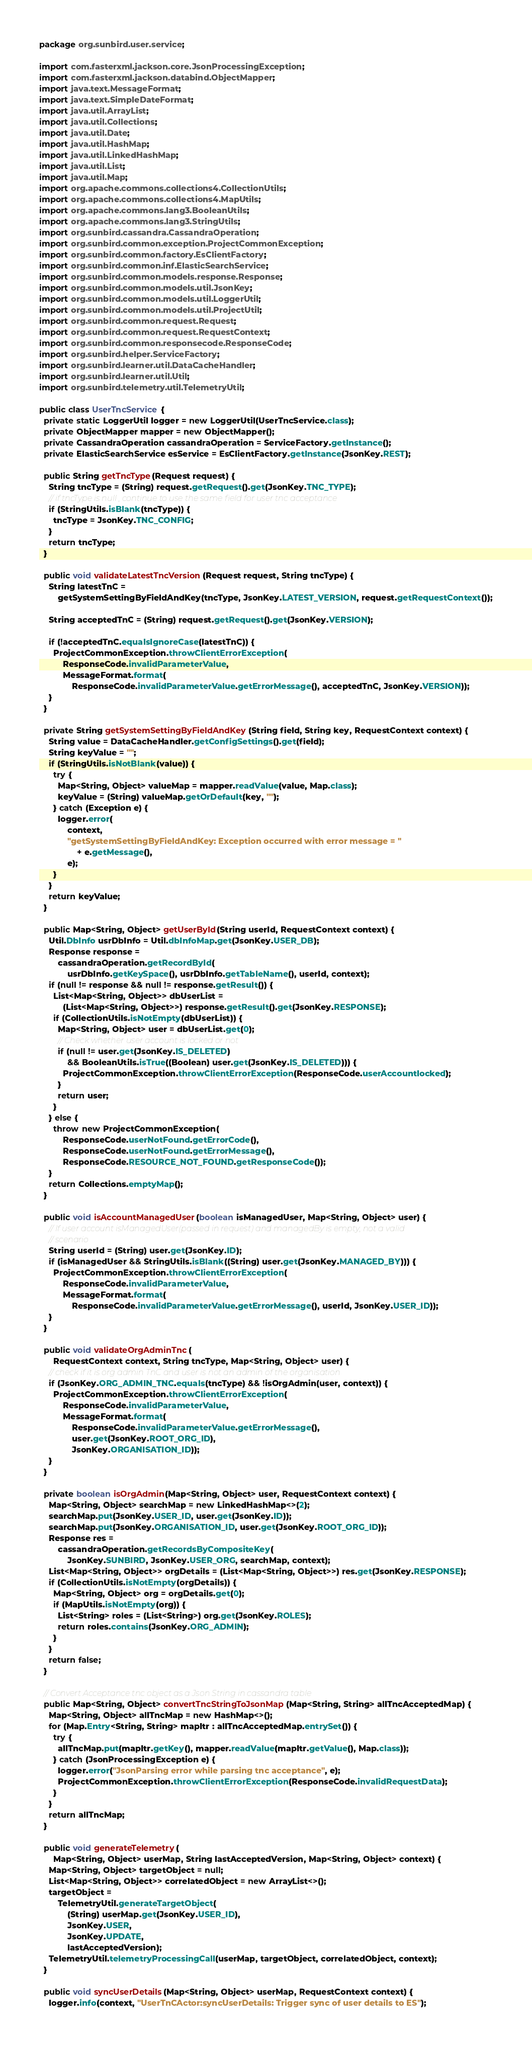Convert code to text. <code><loc_0><loc_0><loc_500><loc_500><_Java_>package org.sunbird.user.service;

import com.fasterxml.jackson.core.JsonProcessingException;
import com.fasterxml.jackson.databind.ObjectMapper;
import java.text.MessageFormat;
import java.text.SimpleDateFormat;
import java.util.ArrayList;
import java.util.Collections;
import java.util.Date;
import java.util.HashMap;
import java.util.LinkedHashMap;
import java.util.List;
import java.util.Map;
import org.apache.commons.collections4.CollectionUtils;
import org.apache.commons.collections4.MapUtils;
import org.apache.commons.lang3.BooleanUtils;
import org.apache.commons.lang3.StringUtils;
import org.sunbird.cassandra.CassandraOperation;
import org.sunbird.common.exception.ProjectCommonException;
import org.sunbird.common.factory.EsClientFactory;
import org.sunbird.common.inf.ElasticSearchService;
import org.sunbird.common.models.response.Response;
import org.sunbird.common.models.util.JsonKey;
import org.sunbird.common.models.util.LoggerUtil;
import org.sunbird.common.models.util.ProjectUtil;
import org.sunbird.common.request.Request;
import org.sunbird.common.request.RequestContext;
import org.sunbird.common.responsecode.ResponseCode;
import org.sunbird.helper.ServiceFactory;
import org.sunbird.learner.util.DataCacheHandler;
import org.sunbird.learner.util.Util;
import org.sunbird.telemetry.util.TelemetryUtil;

public class UserTncService {
  private static LoggerUtil logger = new LoggerUtil(UserTncService.class);
  private ObjectMapper mapper = new ObjectMapper();
  private CassandraOperation cassandraOperation = ServiceFactory.getInstance();
  private ElasticSearchService esService = EsClientFactory.getInstance(JsonKey.REST);

  public String getTncType(Request request) {
    String tncType = (String) request.getRequest().get(JsonKey.TNC_TYPE);
    // if tncType is null , continue to use the same field for user tnc acceptance
    if (StringUtils.isBlank(tncType)) {
      tncType = JsonKey.TNC_CONFIG;
    }
    return tncType;
  }

  public void validateLatestTncVersion(Request request, String tncType) {
    String latestTnC =
        getSystemSettingByFieldAndKey(tncType, JsonKey.LATEST_VERSION, request.getRequestContext());

    String acceptedTnC = (String) request.getRequest().get(JsonKey.VERSION);

    if (!acceptedTnC.equalsIgnoreCase(latestTnC)) {
      ProjectCommonException.throwClientErrorException(
          ResponseCode.invalidParameterValue,
          MessageFormat.format(
              ResponseCode.invalidParameterValue.getErrorMessage(), acceptedTnC, JsonKey.VERSION));
    }
  }

  private String getSystemSettingByFieldAndKey(String field, String key, RequestContext context) {
    String value = DataCacheHandler.getConfigSettings().get(field);
    String keyValue = "";
    if (StringUtils.isNotBlank(value)) {
      try {
        Map<String, Object> valueMap = mapper.readValue(value, Map.class);
        keyValue = (String) valueMap.getOrDefault(key, "");
      } catch (Exception e) {
        logger.error(
            context,
            "getSystemSettingByFieldAndKey: Exception occurred with error message = "
                + e.getMessage(),
            e);
      }
    }
    return keyValue;
  }

  public Map<String, Object> getUserById(String userId, RequestContext context) {
    Util.DbInfo usrDbInfo = Util.dbInfoMap.get(JsonKey.USER_DB);
    Response response =
        cassandraOperation.getRecordById(
            usrDbInfo.getKeySpace(), usrDbInfo.getTableName(), userId, context);
    if (null != response && null != response.getResult()) {
      List<Map<String, Object>> dbUserList =
          (List<Map<String, Object>>) response.getResult().get(JsonKey.RESPONSE);
      if (CollectionUtils.isNotEmpty(dbUserList)) {
        Map<String, Object> user = dbUserList.get(0);
        // Check whether user account is locked or not
        if (null != user.get(JsonKey.IS_DELETED)
            && BooleanUtils.isTrue((Boolean) user.get(JsonKey.IS_DELETED))) {
          ProjectCommonException.throwClientErrorException(ResponseCode.userAccountlocked);
        }
        return user;
      }
    } else {
      throw new ProjectCommonException(
          ResponseCode.userNotFound.getErrorCode(),
          ResponseCode.userNotFound.getErrorMessage(),
          ResponseCode.RESOURCE_NOT_FOUND.getResponseCode());
    }
    return Collections.emptyMap();
  }

  public void isAccountManagedUser(boolean isManagedUser, Map<String, Object> user) {
    // If user account isManagedUser(passed in request) and managedBy is empty, not a valid
    // scenario
    String userId = (String) user.get(JsonKey.ID);
    if (isManagedUser && StringUtils.isBlank((String) user.get(JsonKey.MANAGED_BY))) {
      ProjectCommonException.throwClientErrorException(
          ResponseCode.invalidParameterValue,
          MessageFormat.format(
              ResponseCode.invalidParameterValue.getErrorMessage(), userId, JsonKey.USER_ID));
    }
  }

  public void validateOrgAdminTnc(
      RequestContext context, String tncType, Map<String, Object> user) {
    // check if it is org admin TnC and user is not an admin of the organisation
    if (JsonKey.ORG_ADMIN_TNC.equals(tncType) && !isOrgAdmin(user, context)) {
      ProjectCommonException.throwClientErrorException(
          ResponseCode.invalidParameterValue,
          MessageFormat.format(
              ResponseCode.invalidParameterValue.getErrorMessage(),
              user.get(JsonKey.ROOT_ORG_ID),
              JsonKey.ORGANISATION_ID));
    }
  }

  private boolean isOrgAdmin(Map<String, Object> user, RequestContext context) {
    Map<String, Object> searchMap = new LinkedHashMap<>(2);
    searchMap.put(JsonKey.USER_ID, user.get(JsonKey.ID));
    searchMap.put(JsonKey.ORGANISATION_ID, user.get(JsonKey.ROOT_ORG_ID));
    Response res =
        cassandraOperation.getRecordsByCompositeKey(
            JsonKey.SUNBIRD, JsonKey.USER_ORG, searchMap, context);
    List<Map<String, Object>> orgDetails = (List<Map<String, Object>>) res.get(JsonKey.RESPONSE);
    if (CollectionUtils.isNotEmpty(orgDetails)) {
      Map<String, Object> org = orgDetails.get(0);
      if (MapUtils.isNotEmpty(org)) {
        List<String> roles = (List<String>) org.get(JsonKey.ROLES);
        return roles.contains(JsonKey.ORG_ADMIN);
      }
    }
    return false;
  }

  // Convert Acceptance tnc object as a Json String in cassandra table
  public Map<String, Object> convertTncStringToJsonMap(Map<String, String> allTncAcceptedMap) {
    Map<String, Object> allTncMap = new HashMap<>();
    for (Map.Entry<String, String> mapItr : allTncAcceptedMap.entrySet()) {
      try {
        allTncMap.put(mapItr.getKey(), mapper.readValue(mapItr.getValue(), Map.class));
      } catch (JsonProcessingException e) {
        logger.error("JsonParsing error while parsing tnc acceptance", e);
        ProjectCommonException.throwClientErrorException(ResponseCode.invalidRequestData);
      }
    }
    return allTncMap;
  }

  public void generateTelemetry(
      Map<String, Object> userMap, String lastAcceptedVersion, Map<String, Object> context) {
    Map<String, Object> targetObject = null;
    List<Map<String, Object>> correlatedObject = new ArrayList<>();
    targetObject =
        TelemetryUtil.generateTargetObject(
            (String) userMap.get(JsonKey.USER_ID),
            JsonKey.USER,
            JsonKey.UPDATE,
            lastAcceptedVersion);
    TelemetryUtil.telemetryProcessingCall(userMap, targetObject, correlatedObject, context);
  }

  public void syncUserDetails(Map<String, Object> userMap, RequestContext context) {
    logger.info(context, "UserTnCActor:syncUserDetails: Trigger sync of user details to ES");</code> 